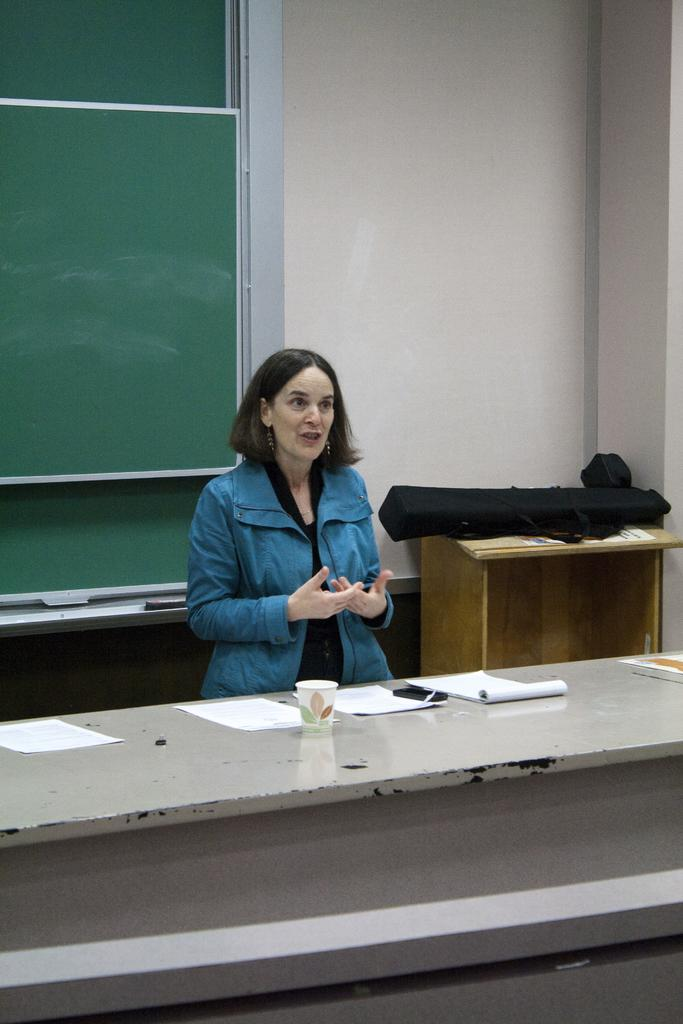Who is the main subject in the image? There is a woman in the image. What is the woman doing in the image? The woman is standing and speaking. What can be seen behind the woman? There is a green board behind the woman. What other objects are present in the image? There is a table, a cup, and a book on the table. What type of suit is the woman wearing in the image? The woman is not wearing a suit in the image; she is wearing a dress. How many planes can be seen flying in the background of the image? There are no planes visible in the image; it only shows a woman, a green board, a table, a cup, and a book. 